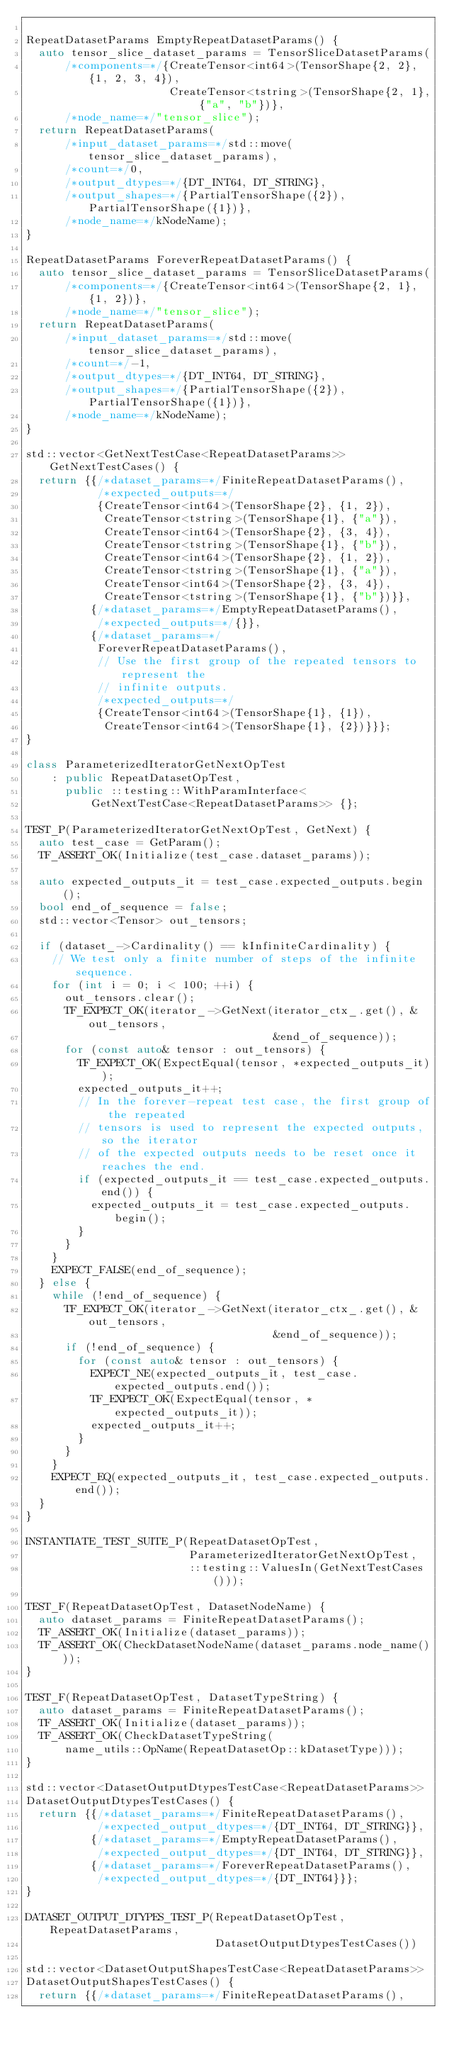Convert code to text. <code><loc_0><loc_0><loc_500><loc_500><_C++_>
RepeatDatasetParams EmptyRepeatDatasetParams() {
  auto tensor_slice_dataset_params = TensorSliceDatasetParams(
      /*components=*/{CreateTensor<int64>(TensorShape{2, 2}, {1, 2, 3, 4}),
                      CreateTensor<tstring>(TensorShape{2, 1}, {"a", "b"})},
      /*node_name=*/"tensor_slice");
  return RepeatDatasetParams(
      /*input_dataset_params=*/std::move(tensor_slice_dataset_params),
      /*count=*/0,
      /*output_dtypes=*/{DT_INT64, DT_STRING},
      /*output_shapes=*/{PartialTensorShape({2}), PartialTensorShape({1})},
      /*node_name=*/kNodeName);
}

RepeatDatasetParams ForeverRepeatDatasetParams() {
  auto tensor_slice_dataset_params = TensorSliceDatasetParams(
      /*components=*/{CreateTensor<int64>(TensorShape{2, 1}, {1, 2})},
      /*node_name=*/"tensor_slice");
  return RepeatDatasetParams(
      /*input_dataset_params=*/std::move(tensor_slice_dataset_params),
      /*count=*/-1,
      /*output_dtypes=*/{DT_INT64, DT_STRING},
      /*output_shapes=*/{PartialTensorShape({2}), PartialTensorShape({1})},
      /*node_name=*/kNodeName);
}

std::vector<GetNextTestCase<RepeatDatasetParams>> GetNextTestCases() {
  return {{/*dataset_params=*/FiniteRepeatDatasetParams(),
           /*expected_outputs=*/
           {CreateTensor<int64>(TensorShape{2}, {1, 2}),
            CreateTensor<tstring>(TensorShape{1}, {"a"}),
            CreateTensor<int64>(TensorShape{2}, {3, 4}),
            CreateTensor<tstring>(TensorShape{1}, {"b"}),
            CreateTensor<int64>(TensorShape{2}, {1, 2}),
            CreateTensor<tstring>(TensorShape{1}, {"a"}),
            CreateTensor<int64>(TensorShape{2}, {3, 4}),
            CreateTensor<tstring>(TensorShape{1}, {"b"})}},
          {/*dataset_params=*/EmptyRepeatDatasetParams(),
           /*expected_outputs=*/{}},
          {/*dataset_params=*/
           ForeverRepeatDatasetParams(),
           // Use the first group of the repeated tensors to represent the
           // infinite outputs.
           /*expected_outputs=*/
           {CreateTensor<int64>(TensorShape{1}, {1}),
            CreateTensor<int64>(TensorShape{1}, {2})}}};
}

class ParameterizedIteratorGetNextOpTest
    : public RepeatDatasetOpTest,
      public ::testing::WithParamInterface<
          GetNextTestCase<RepeatDatasetParams>> {};

TEST_P(ParameterizedIteratorGetNextOpTest, GetNext) {
  auto test_case = GetParam();
  TF_ASSERT_OK(Initialize(test_case.dataset_params));

  auto expected_outputs_it = test_case.expected_outputs.begin();
  bool end_of_sequence = false;
  std::vector<Tensor> out_tensors;

  if (dataset_->Cardinality() == kInfiniteCardinality) {
    // We test only a finite number of steps of the infinite sequence.
    for (int i = 0; i < 100; ++i) {
      out_tensors.clear();
      TF_EXPECT_OK(iterator_->GetNext(iterator_ctx_.get(), &out_tensors,
                                      &end_of_sequence));
      for (const auto& tensor : out_tensors) {
        TF_EXPECT_OK(ExpectEqual(tensor, *expected_outputs_it));
        expected_outputs_it++;
        // In the forever-repeat test case, the first group of the repeated
        // tensors is used to represent the expected outputs, so the iterator
        // of the expected outputs needs to be reset once it reaches the end.
        if (expected_outputs_it == test_case.expected_outputs.end()) {
          expected_outputs_it = test_case.expected_outputs.begin();
        }
      }
    }
    EXPECT_FALSE(end_of_sequence);
  } else {
    while (!end_of_sequence) {
      TF_EXPECT_OK(iterator_->GetNext(iterator_ctx_.get(), &out_tensors,
                                      &end_of_sequence));
      if (!end_of_sequence) {
        for (const auto& tensor : out_tensors) {
          EXPECT_NE(expected_outputs_it, test_case.expected_outputs.end());
          TF_EXPECT_OK(ExpectEqual(tensor, *expected_outputs_it));
          expected_outputs_it++;
        }
      }
    }
    EXPECT_EQ(expected_outputs_it, test_case.expected_outputs.end());
  }
}

INSTANTIATE_TEST_SUITE_P(RepeatDatasetOpTest,
                         ParameterizedIteratorGetNextOpTest,
                         ::testing::ValuesIn(GetNextTestCases()));

TEST_F(RepeatDatasetOpTest, DatasetNodeName) {
  auto dataset_params = FiniteRepeatDatasetParams();
  TF_ASSERT_OK(Initialize(dataset_params));
  TF_ASSERT_OK(CheckDatasetNodeName(dataset_params.node_name()));
}

TEST_F(RepeatDatasetOpTest, DatasetTypeString) {
  auto dataset_params = FiniteRepeatDatasetParams();
  TF_ASSERT_OK(Initialize(dataset_params));
  TF_ASSERT_OK(CheckDatasetTypeString(
      name_utils::OpName(RepeatDatasetOp::kDatasetType)));
}

std::vector<DatasetOutputDtypesTestCase<RepeatDatasetParams>>
DatasetOutputDtypesTestCases() {
  return {{/*dataset_params=*/FiniteRepeatDatasetParams(),
           /*expected_output_dtypes=*/{DT_INT64, DT_STRING}},
          {/*dataset_params=*/EmptyRepeatDatasetParams(),
           /*expected_output_dtypes=*/{DT_INT64, DT_STRING}},
          {/*dataset_params=*/ForeverRepeatDatasetParams(),
           /*expected_output_dtypes=*/{DT_INT64}}};
}

DATASET_OUTPUT_DTYPES_TEST_P(RepeatDatasetOpTest, RepeatDatasetParams,
                             DatasetOutputDtypesTestCases())

std::vector<DatasetOutputShapesTestCase<RepeatDatasetParams>>
DatasetOutputShapesTestCases() {
  return {{/*dataset_params=*/FiniteRepeatDatasetParams(),</code> 